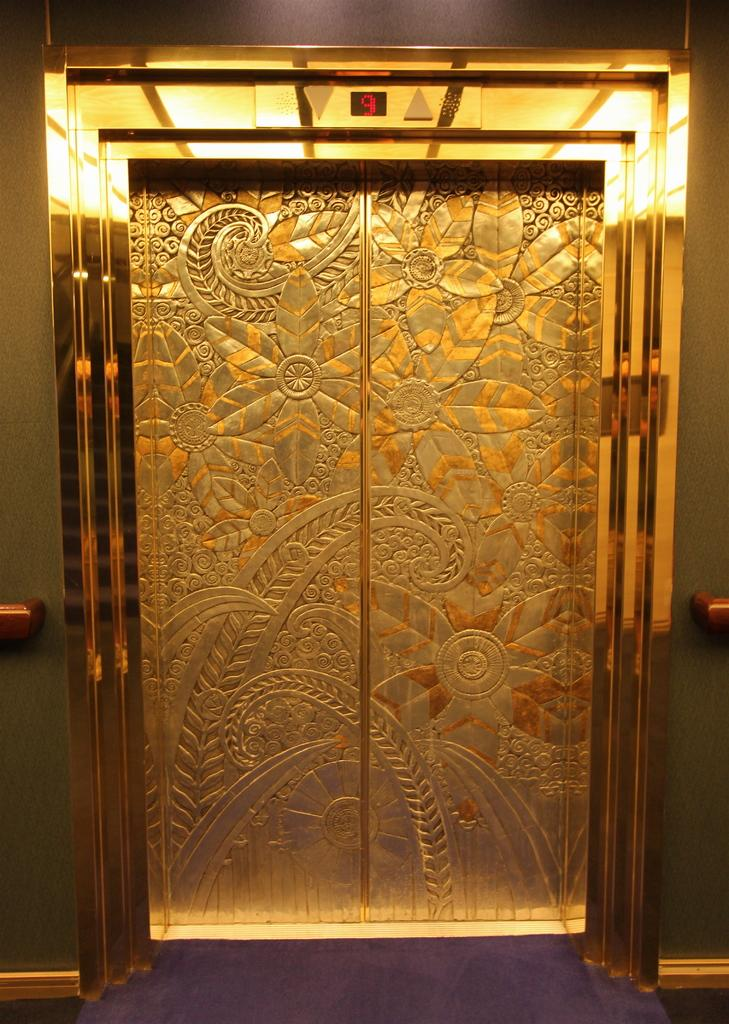What is the main subject of the image? The main subject of the image is a door of a lift. Can you describe the door in the image? The door is the entrance to a lift. What number is written on the door of the lift in the image? There is no number visible on the door of the lift in the image. 